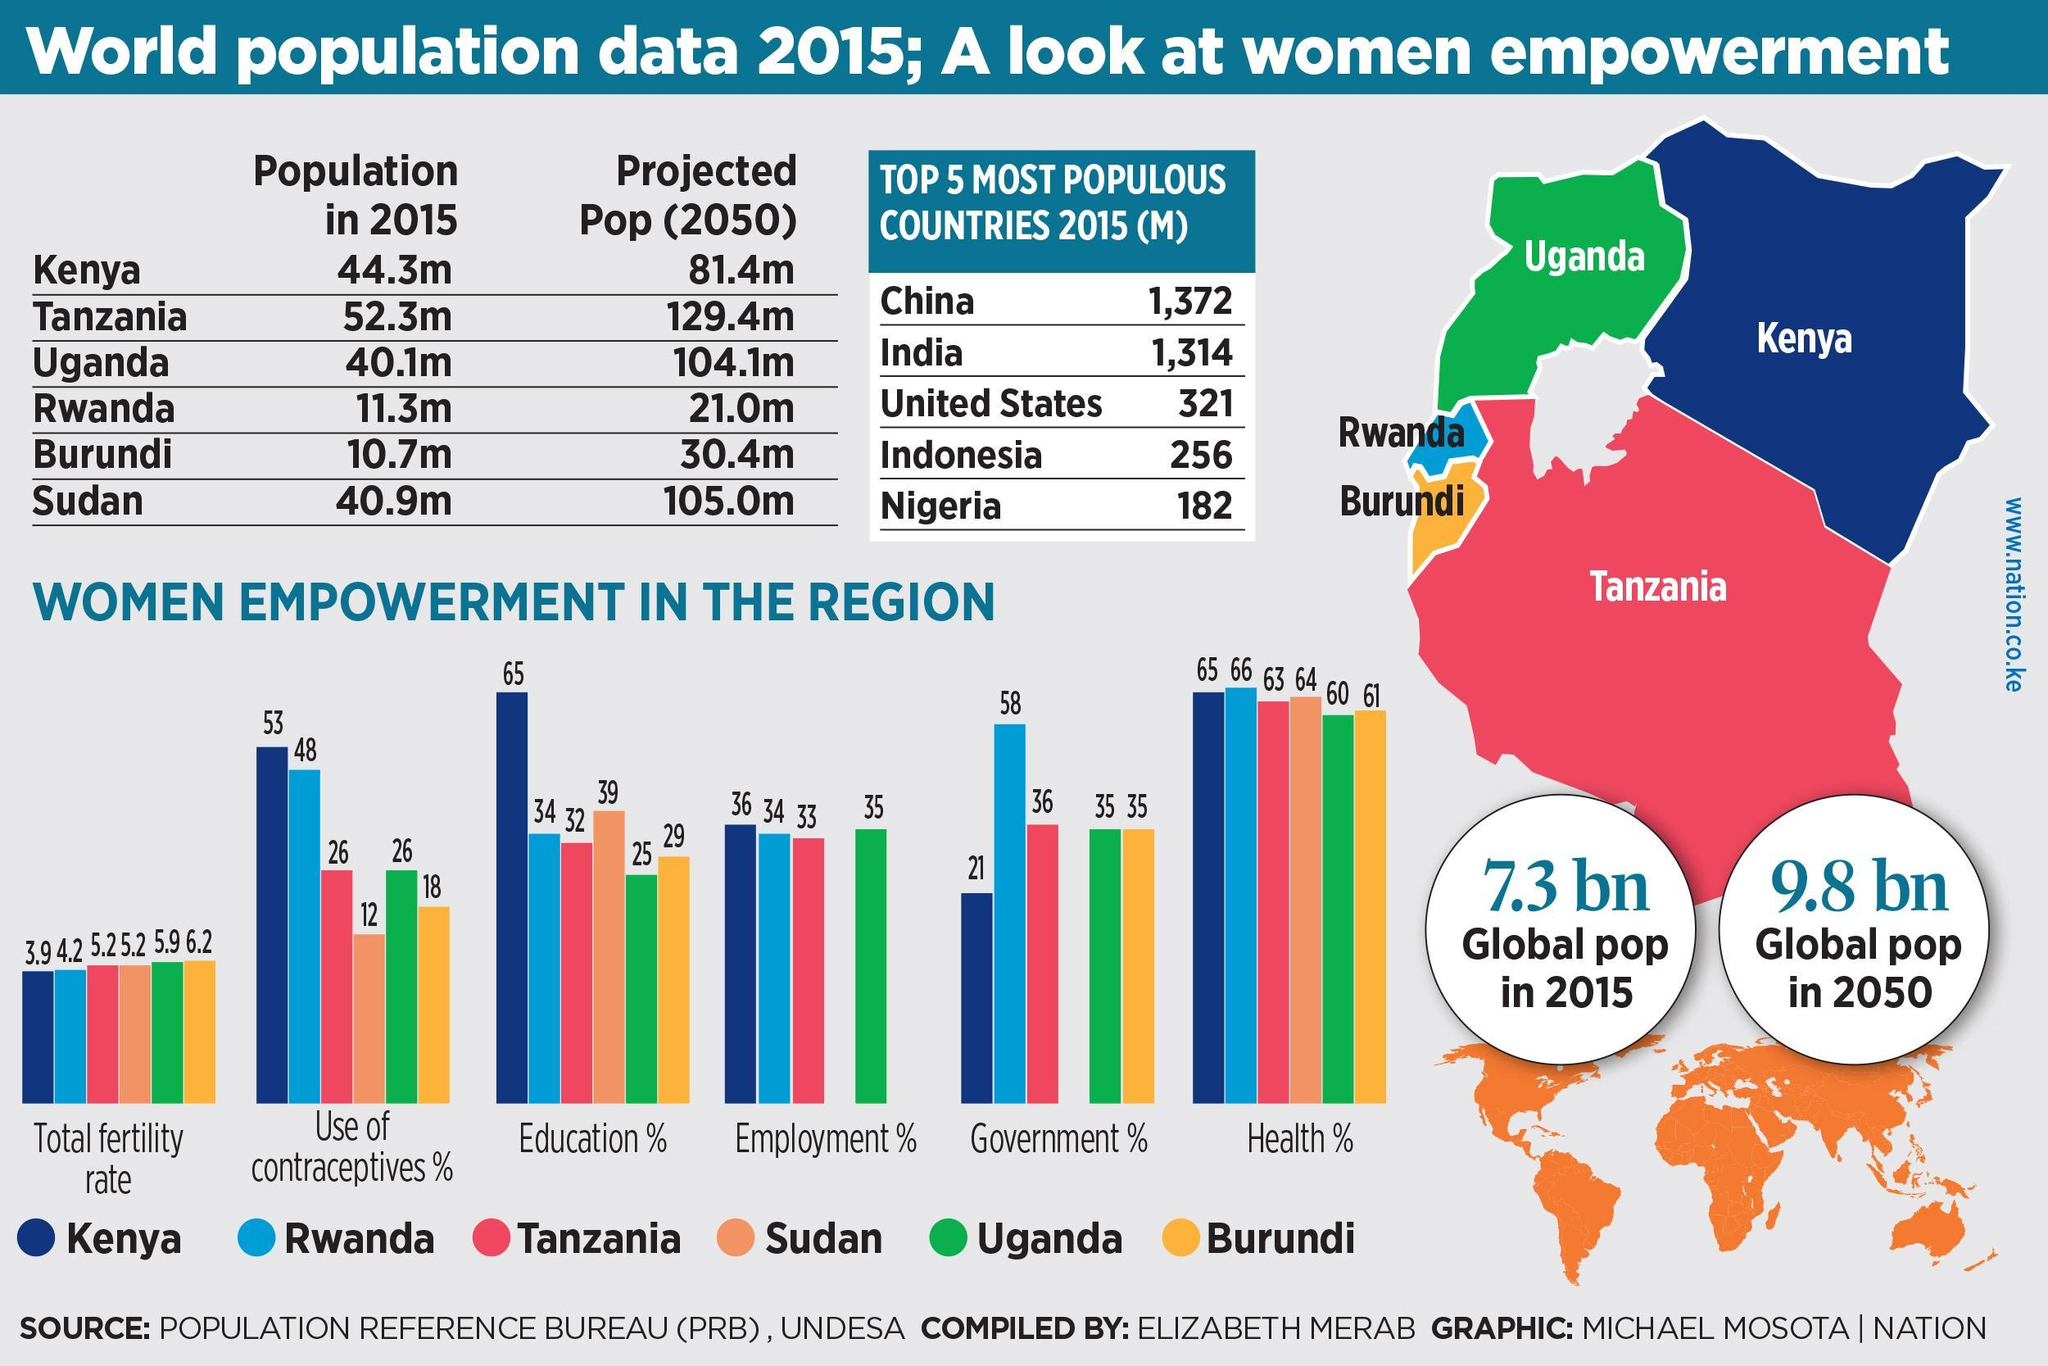What is the percentage of women empowerment in the health sector of Burundi and Rwanda, taken together?
Answer the question with a short phrase. 127 What is the percentage of women empowerment in the government sector of Tanzania and Kenya, taken together? 57 What is the difference between the projected population and population in 2015 of Kenya? 37.1m Which color used to represent Tanzania-blue, green, red, orange? red Which color used to represent Kenya-yellow, green, blue, orange? blue What is the percentage of women empowerment in the employment sector of Uganda and Kenya, taken together? 71 What is the percentage of total fertility rate in Kenya and Rwanda, taken together? 8.1 